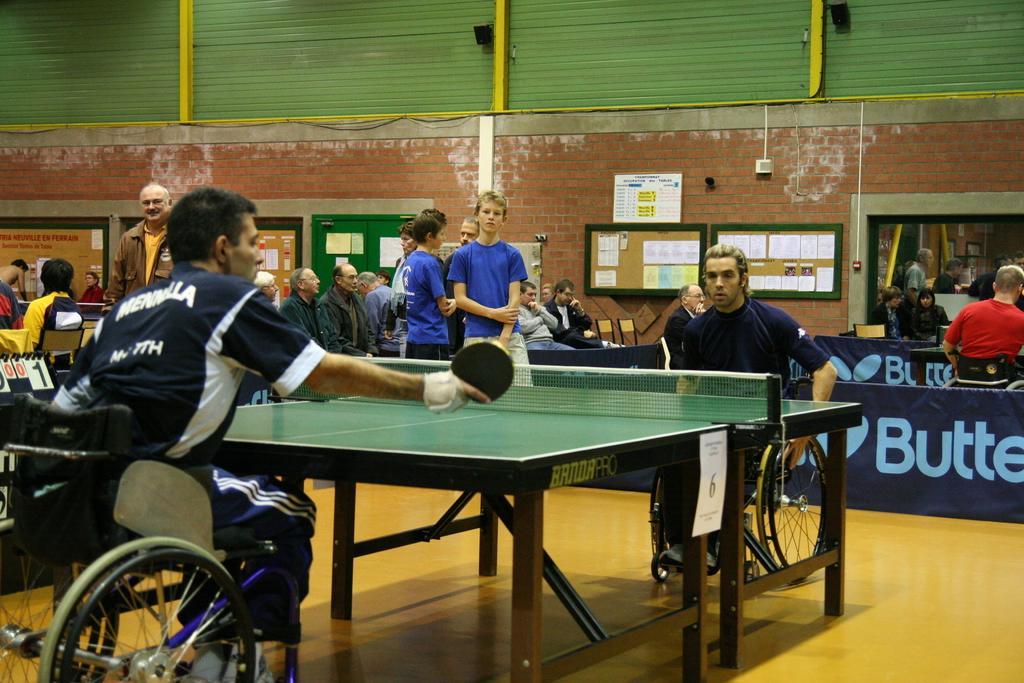Could you give a brief overview of what you see in this image? In this image we can see this persons are sitting on the wheel chairs and playing table tennis. In the background we can see many people, notice boards and a brick wall. 